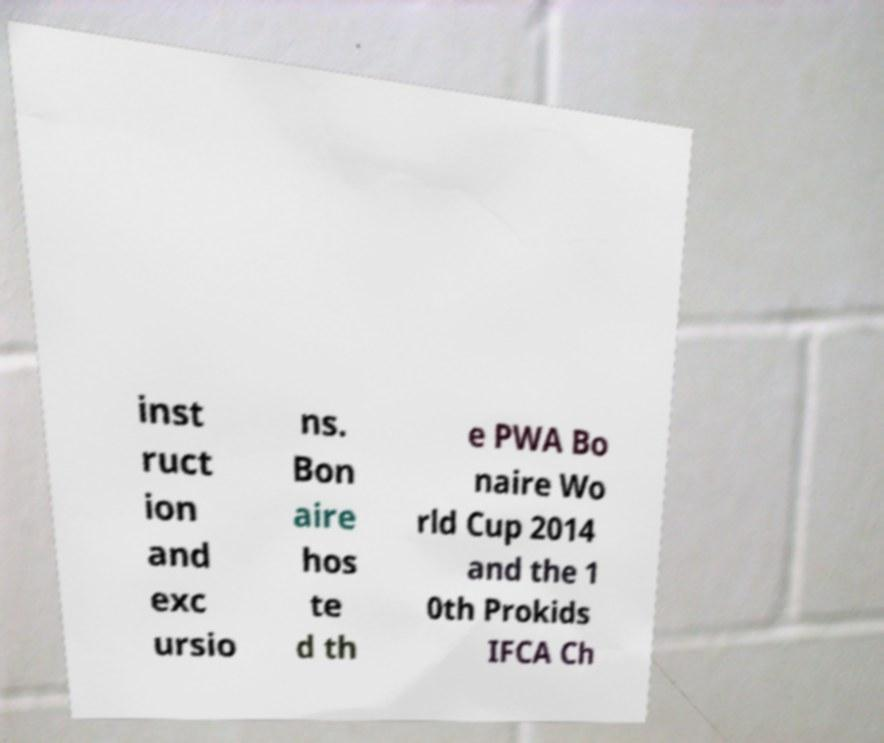I need the written content from this picture converted into text. Can you do that? inst ruct ion and exc ursio ns. Bon aire hos te d th e PWA Bo naire Wo rld Cup 2014 and the 1 0th Prokids IFCA Ch 